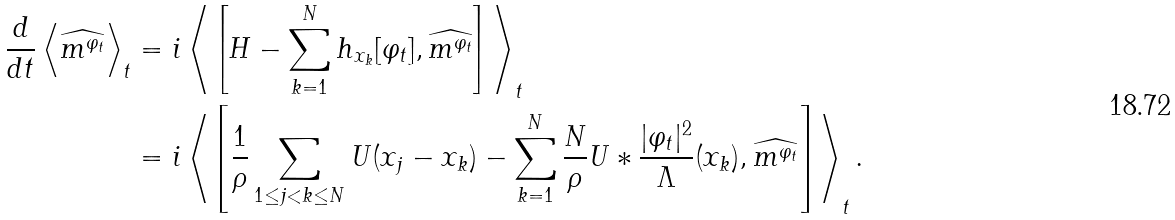Convert formula to latex. <formula><loc_0><loc_0><loc_500><loc_500>\frac { d } { d t } \left \langle \widehat { m ^ { \varphi _ { t } } } \right \rangle _ { t } & = i \left \langle \left [ H - \sum _ { k = 1 } ^ { N } h _ { x _ { k } } [ \varphi _ { t } ] , \widehat { m ^ { \varphi _ { t } } } \right ] \right \rangle _ { t } \\ & = i \left \langle \left [ \frac { 1 } { \rho } \sum _ { 1 \leq j < k \leq N } U ( x _ { j } - x _ { k } ) - \sum _ { k = 1 } ^ { N } \frac { N } { \rho } U * \frac { | \varphi _ { t } | ^ { 2 } } { \Lambda } ( x _ { k } ) , \widehat { m ^ { \varphi _ { t } } } \right ] \right \rangle _ { t } .</formula> 